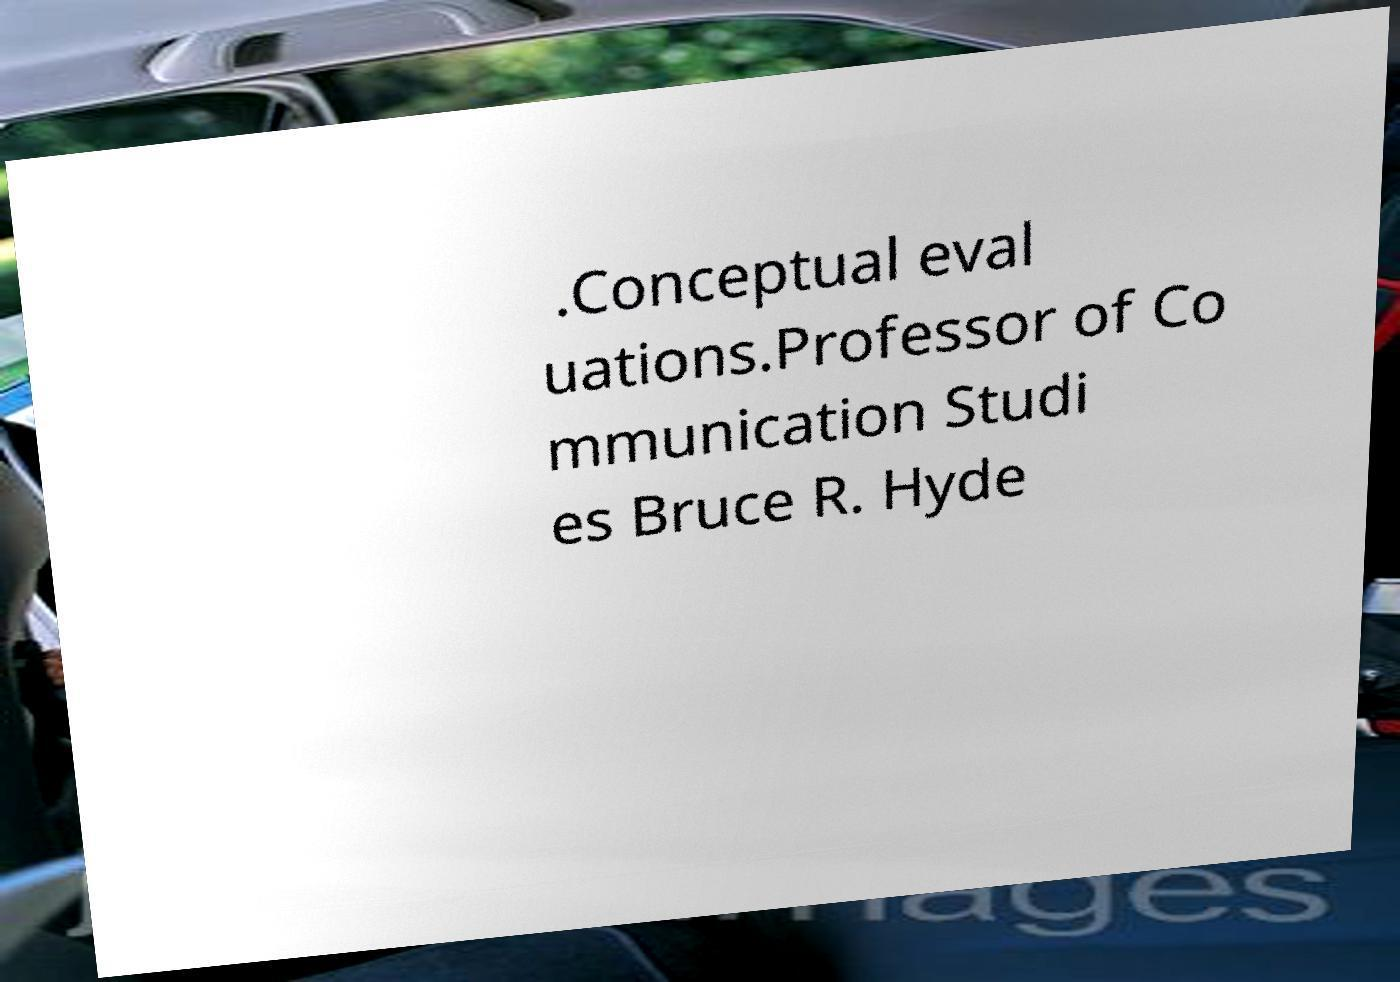There's text embedded in this image that I need extracted. Can you transcribe it verbatim? .Conceptual eval uations.Professor of Co mmunication Studi es Bruce R. Hyde 